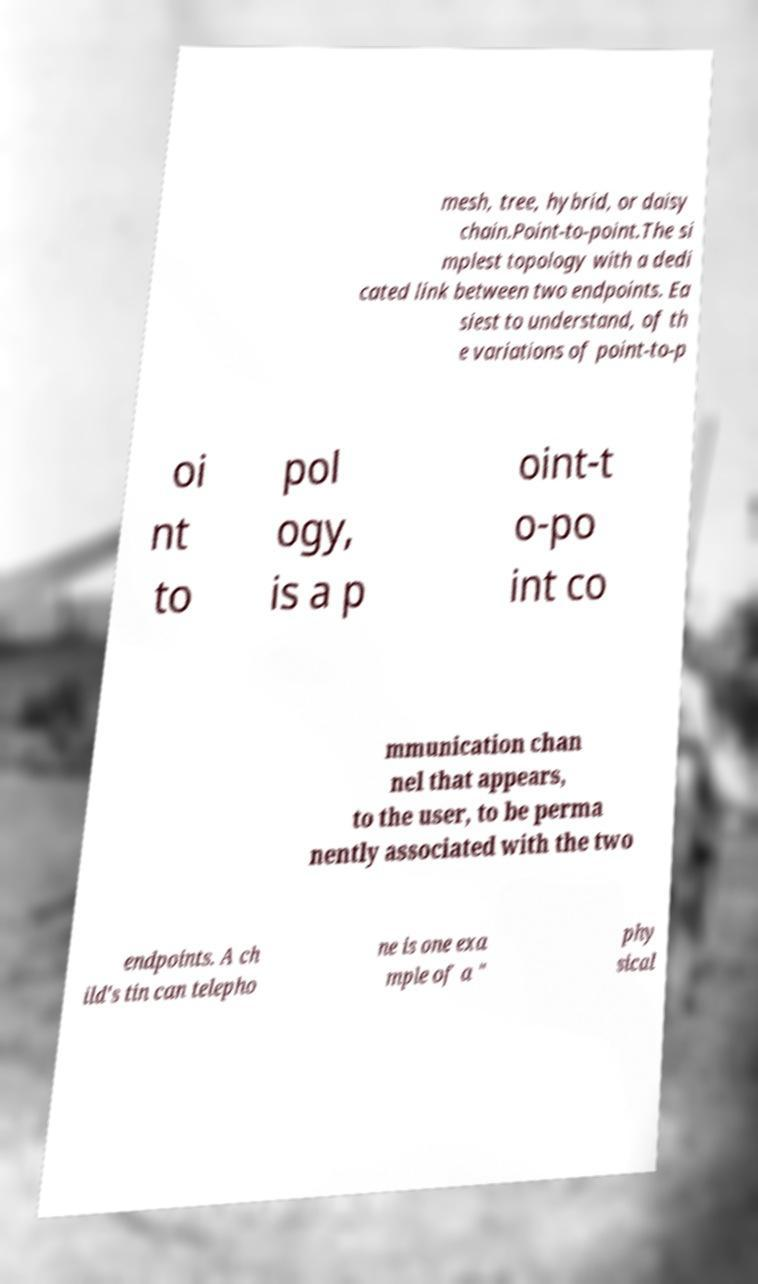Can you accurately transcribe the text from the provided image for me? mesh, tree, hybrid, or daisy chain.Point-to-point.The si mplest topology with a dedi cated link between two endpoints. Ea siest to understand, of th e variations of point-to-p oi nt to pol ogy, is a p oint-t o-po int co mmunication chan nel that appears, to the user, to be perma nently associated with the two endpoints. A ch ild's tin can telepho ne is one exa mple of a " phy sical 